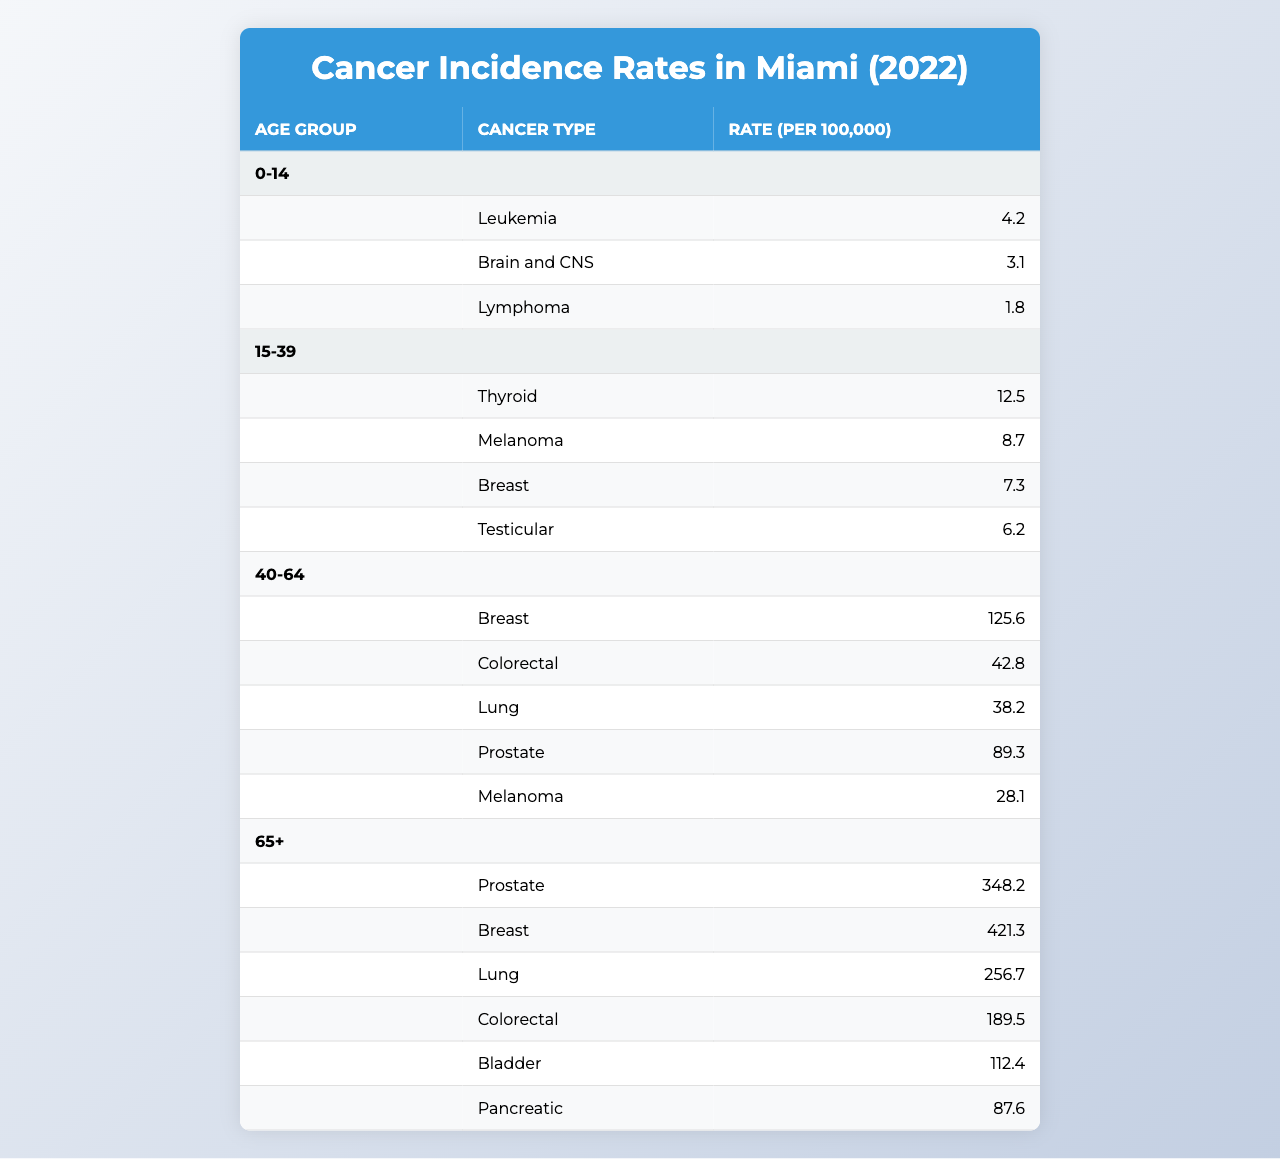What is the cancer type with the highest incidence rate in the 65+ age group? In the 65+ age group, the cancer types listed are Prostate, Breast, Lung, Colorectal, Bladder, and Pancreatic. Among these, Breast cancer has the highest incidence rate at 421.3 per 100,000.
Answer: Breast Which age group has the highest overall cancer incidence rate? To determine this, we need to compare the rates of all age groups. The rates are: 0-14 = 4.2, 15-39 = 34.7 (sum of 12.5, 8.7, 7.3, 6.2), 40-64 = 324.6 (sum of 125.6, 42.8, 38.2, 89.3, 28.1), and 65+ = 1016.3 (sum of 348.2, 421.3, 256.7, 189.5, 112.4, 87.6). The 65+ age group has the highest overall rate at 1016.3.
Answer: 65+ What is the incidence rate of colorectal cancer in the 40-64 age group? The table indicates that in the 40-64 age group, the incidence rate of colorectal cancer is 42.8 per 100,000.
Answer: 42.8 Is the incidence rate of melanoma higher in the 15-39 or 40-64 age group? The incidence rate of melanoma in the 15-39 age group is 8.7, while in the 40-64 age group, it is 28.1. Since 28.1 is greater than 8.7, melanoma has a higher incidence rate in the 40-64 age group.
Answer: Yes What is the total incidence rate of all cancer types for the 15-39 age group? For the 15-39 age group, the cancer types listed are Thyroid (12.5), Melanoma (8.7), Breast (7.3), and Testicular (6.2). Adding these values: 12.5 + 8.7 + 7.3 + 6.2 equals 34.7 per 100,000, which is the total incidence for this age group.
Answer: 34.7 Are there any cancer types that have an incidence rate of 0 in the data? Reviewing the table for all age groups and cancer types shows that each listed cancer type has a non-zero incidence rate. Therefore, there are no cancer types with an incidence rate of 0 in the data.
Answer: No What is the average incidence rate of lung cancer across all age groups? Lung cancer incidence rates are 38.2 in the 40-64 age group and 256.7 in the 65+ age group. The average is calculated as (38.2 + 256.7)/2 = 147.45.
Answer: 147.45 In how many age groups is breast cancer reported? Breast cancer is reported in three age groups: 15-39, 40-64, and 65+. Therefore, breast cancer is reported in three distinct age groups.
Answer: Three Which cancer type has the lowest incidence rate in the 0-14 age group? In the 0-14 age group, the cancer types listed are Leukemia (4.2), Brain and CNS (3.1), and Lymphoma (1.8). The lowest rate among these is Lymphoma at 1.8 per 100,000.
Answer: Lymphoma What is the difference in incidence rate of prostate cancer between the 40-64 and 65+ age groups? The incidence rate of prostate cancer is 89.3 in the 40-64 age group and 348.2 in the 65+ age group. The difference is calculated as 348.2 - 89.3 = 258.9 per 100,000.
Answer: 258.9 